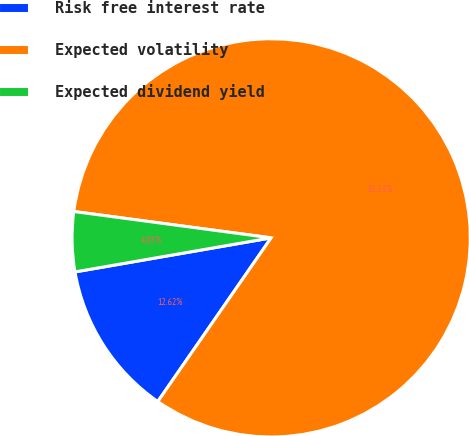Convert chart. <chart><loc_0><loc_0><loc_500><loc_500><pie_chart><fcel>Risk free interest rate<fcel>Expected volatility<fcel>Expected dividend yield<nl><fcel>12.62%<fcel>82.52%<fcel>4.85%<nl></chart> 